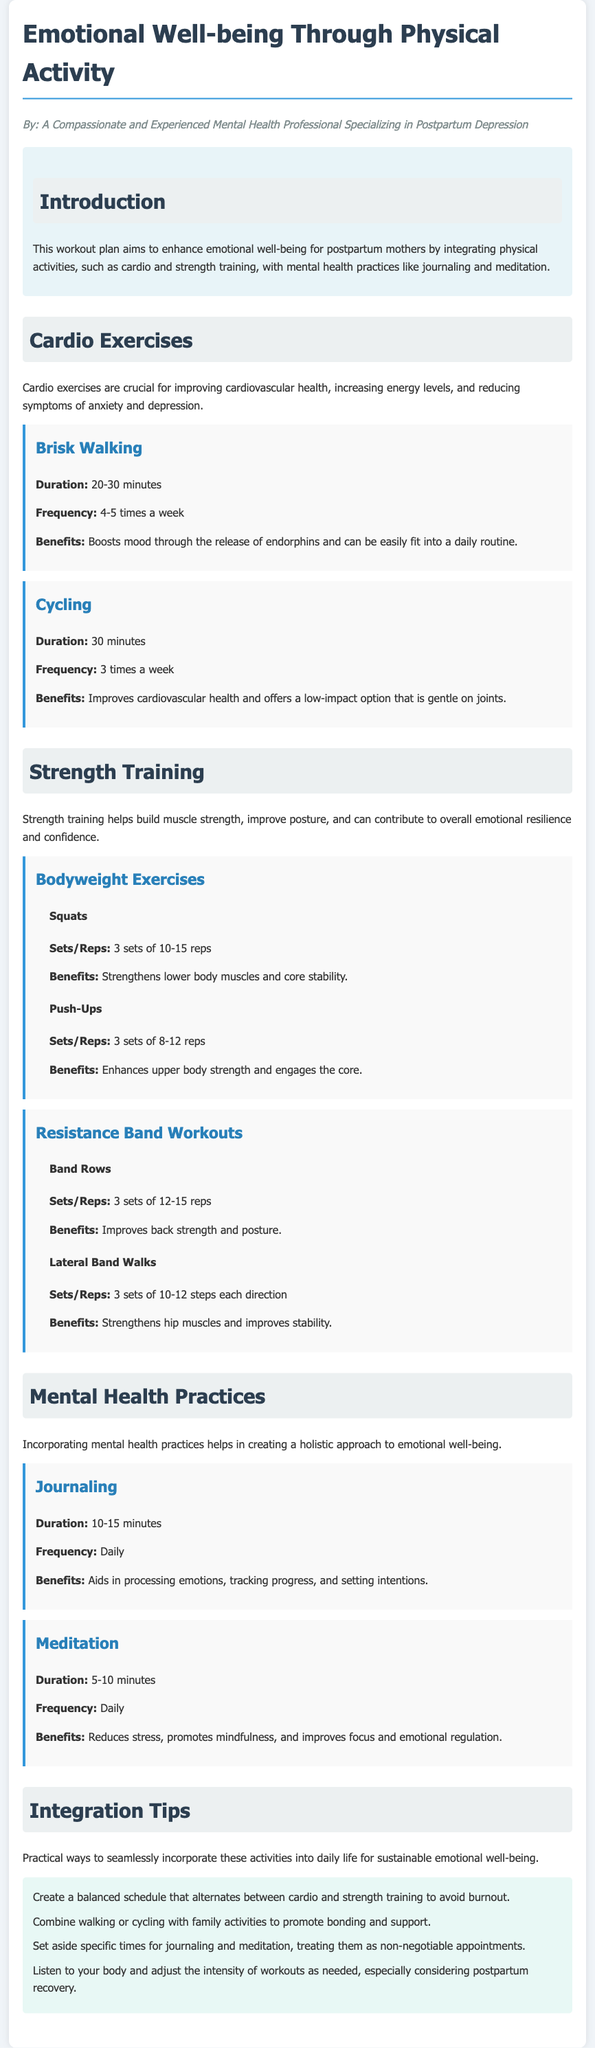what is the title of the document? The title of the document is the main heading at the top, which is "Emotional Well-being Through Physical Activity."
Answer: Emotional Well-being Through Physical Activity who is the author of the document? The author is specified in the persona section at the beginning, which describes their experience and specialization.
Answer: A Compassionate and Experienced Mental Health Professional Specializing in Postpartum Depression how long should a brisk walk last? The document mentions the duration for brisk walking under cardio exercises.
Answer: 20-30 minutes how often should cycling be done according to the plan? The frequency for cycling is provided in the cardio exercises section of the document.
Answer: 3 times a week what are the benefits of journaling? The benefits of journaling are listed in the mental health practices section and are meant to support emotional processing.
Answer: Aids in processing emotions, tracking progress, and setting intentions what is one way to combine physical activity with family? The integration tips suggest a practical way to incorporate activities into family life.
Answer: Combine walking or cycling with family activities to promote bonding and support how many sets and reps are recommended for squats? This information is found under the bodyweight exercises section for strength training.
Answer: 3 sets of 10-15 reps what is the duration for meditation mentioned in the document? The document specifies the duration for meditation in the mental health practices section.
Answer: 5-10 minutes 